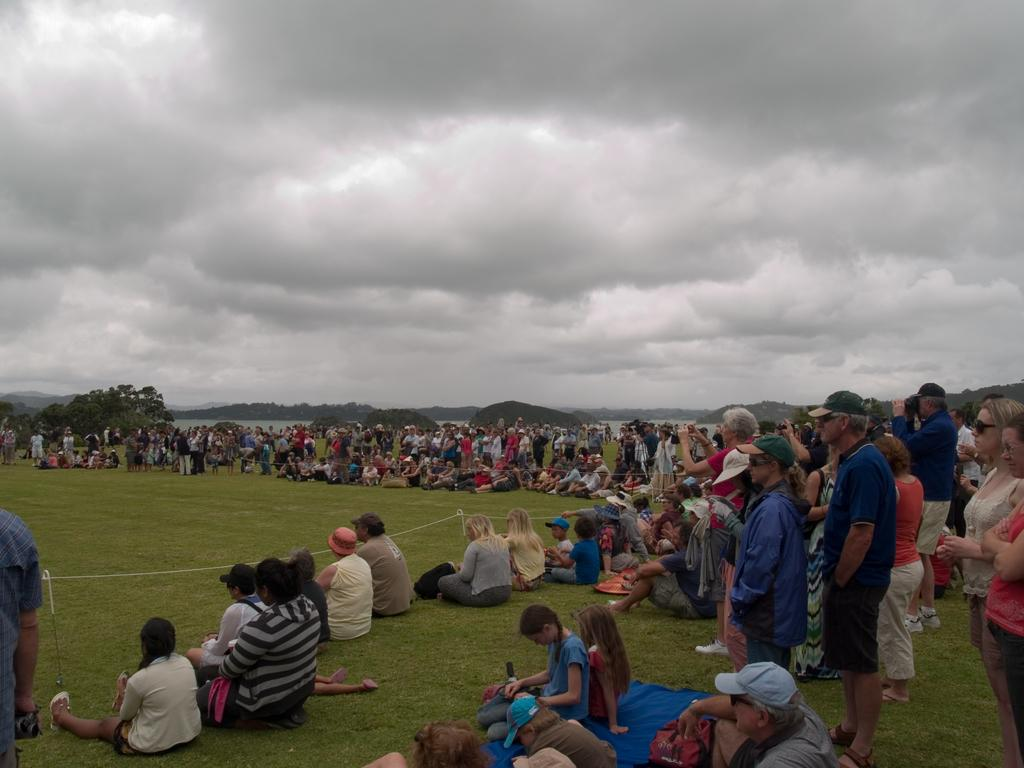What are the people at the bottom of the image doing? Some people are sitting, and some are standing at the bottom of the image. What can be seen in the background of the image? There is a river, hills, and the sky visible in the background of the image. What type of education can be seen taking place in the image? There is no indication of education in the image; it primarily features people and a natural background. 